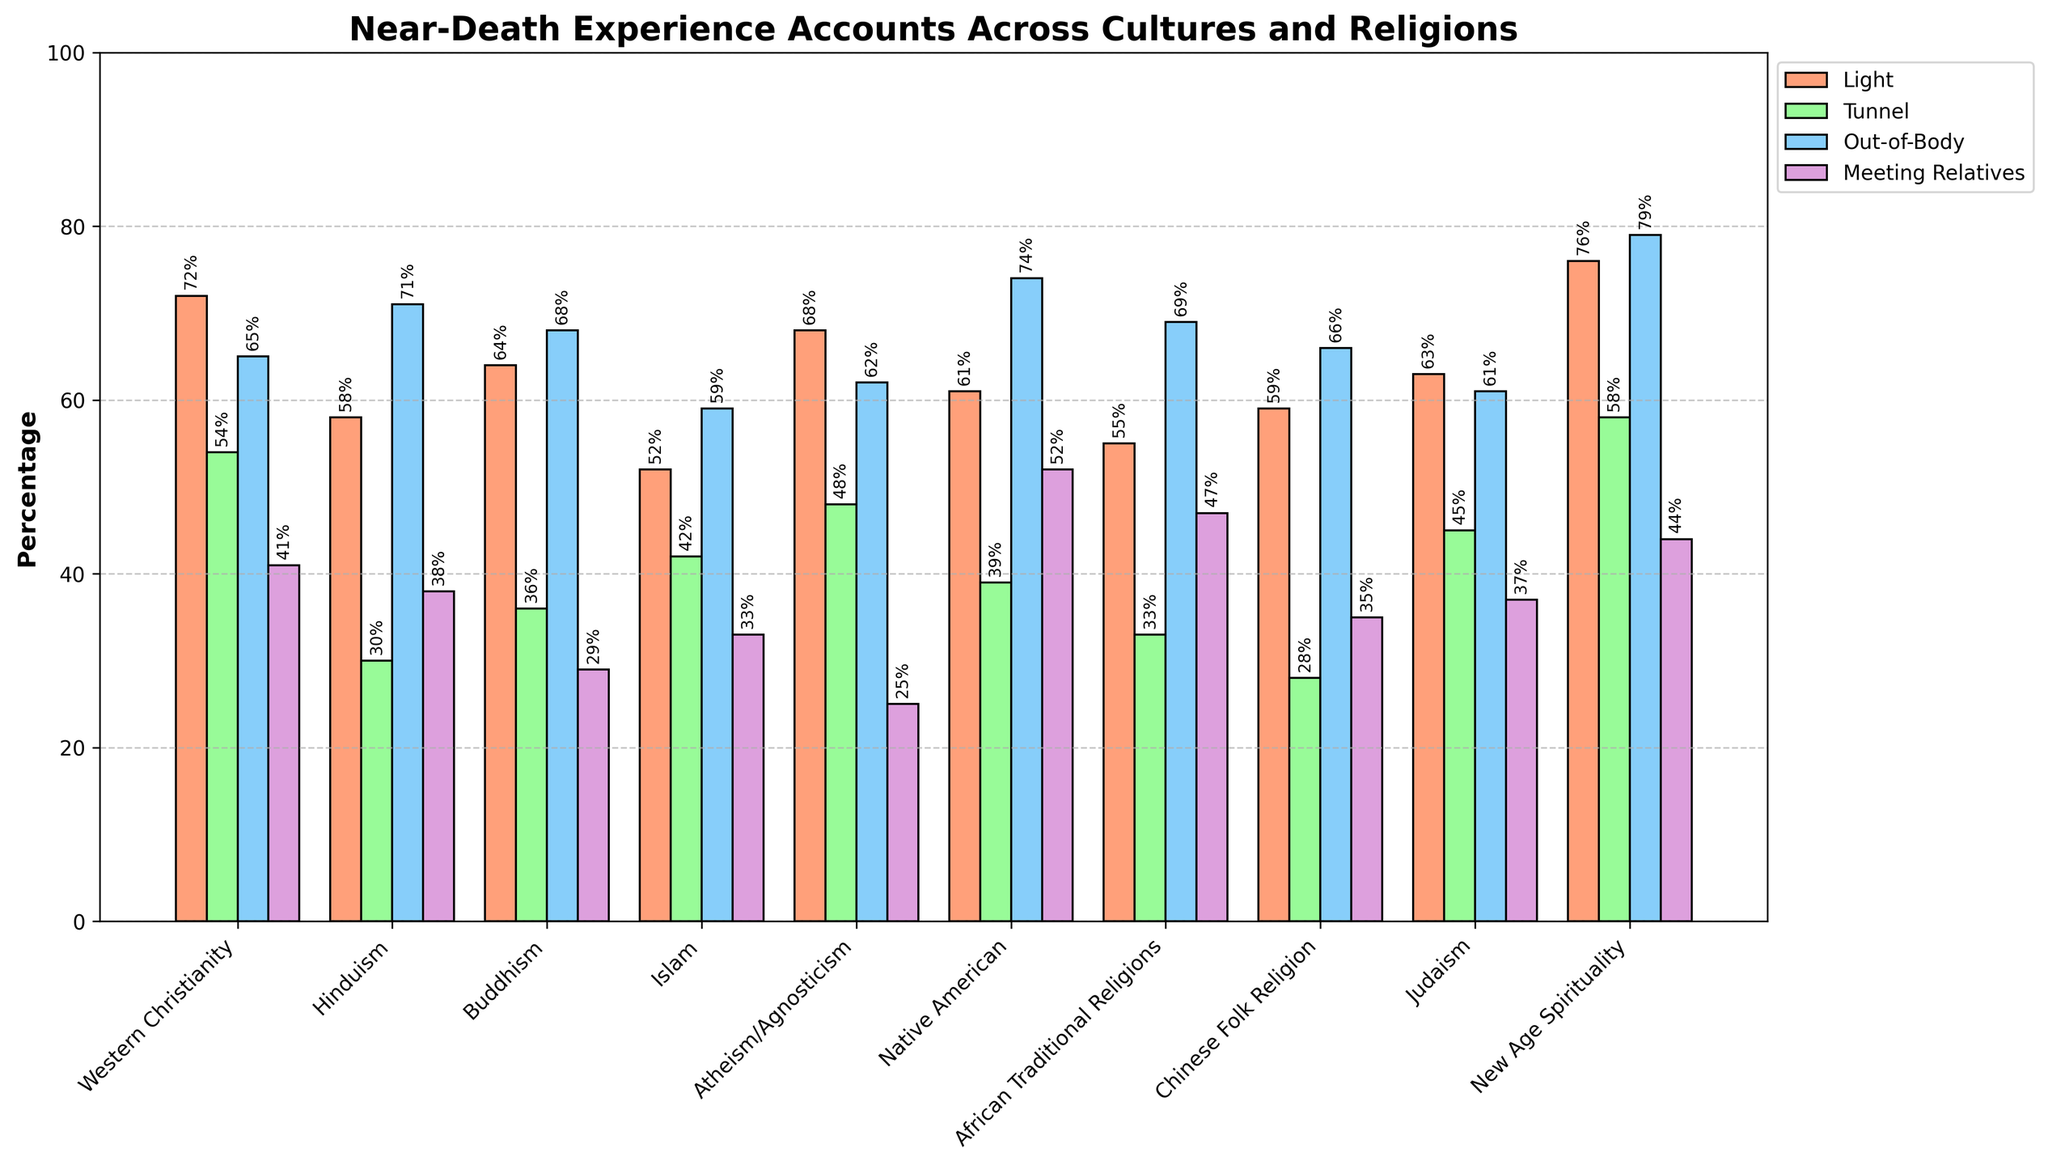What's the highest percentage of people reporting Light, and which culture/religion does it correspond to? Identify the bar with the greatest height in the 'Light' category. The highest bar in the 'Light' category represents New Age Spirituality with a percentage of 76%.
Answer: New Age Spirituality, 76% Which culture/religion has the lowest percentage reporting Meeting Deceased Relatives? Look for the shortest bar in the 'Meeting Deceased Relatives' category. The shortest bar in this category corresponds to Atheism/Agnosticism with a percentage of 25%.
Answer: Atheism/Agnosticism, 25% Compare the percentage of people reporting Out-of-Body Experiences between Hinduism and Islam. Which one has a higher percentage, and by how much? Find the heights of the 'Out-of-Body Experience' bars for both Hinduism and Islam. Hinduism has 71% and Islam has 59%. Hinduism's percentage is higher by 12%.
Answer: Hinduism, 12% What is the average percentage of Reporting Tunnel in Western Christianity, Buddhism, and Judaism? Sum the percentages of Reporting Tunnel for Western Christianity (54), Buddhism (36), and Judaism (45), then divide by 3. The sum is 135, and the average is 135/3 = 45.
Answer: 45% Which three cultures/religions report the highest percentage of Out-of-Body Experiences, and what are the percentages? Identify the top three highest bars in the 'Out-of-Body Experience' category. The top three cultures/religions are New Age Spirituality (79%), Native American (74%), and African Traditional Religions (69%).
Answer: New Age Spirituality: 79%, Native American: 74%, African Traditional Religions: 69% Does the percentage of people reporting Meeting Deceased Relatives in Native American culture exceed that in Western Christianity? If so, by how much? Look at the bar heights for 'Meeting Deceased Relatives' in both Native American culture (52%) and Western Christianity (41%). Subtract the smaller percentage from the larger one to find the difference (52% - 41% = 11%).
Answer: Yes, by 11% What is the combined percentage of people reporting Tunnel and Meeting Deceased Relatives in Buddhism? Sum the percentages of 'Tunnel' (36%) and 'Meeting Deceased Relatives' (29%) in Buddhism. The combined percentage is 36 + 29 = 65.
Answer: 65% Which culture/religion has the highest differences between Reporting Light and Tunnel percentages and what is that difference? Calculate the differences for each culture/religion and find the maximum difference. New Age Spirituality has the highest difference where Light is 76% and Tunnel is 58%, resulting in a difference of 18%.
Answer: New Age Spirituality, difference of 18% What are the visual patterns seen in the percentage of Out-of-Body Experiences compared to the Meeting Deceased Relatives across cultures/religions? Generally, the 'Out-of-Body Experience' bars are taller than the 'Meeting Deceased Relatives' bars for most cultures/religions. This indicates that the reported percentage of Out-of-Body Experiences is generally higher.
Answer: Out-of-Body Experiences are generally higher 